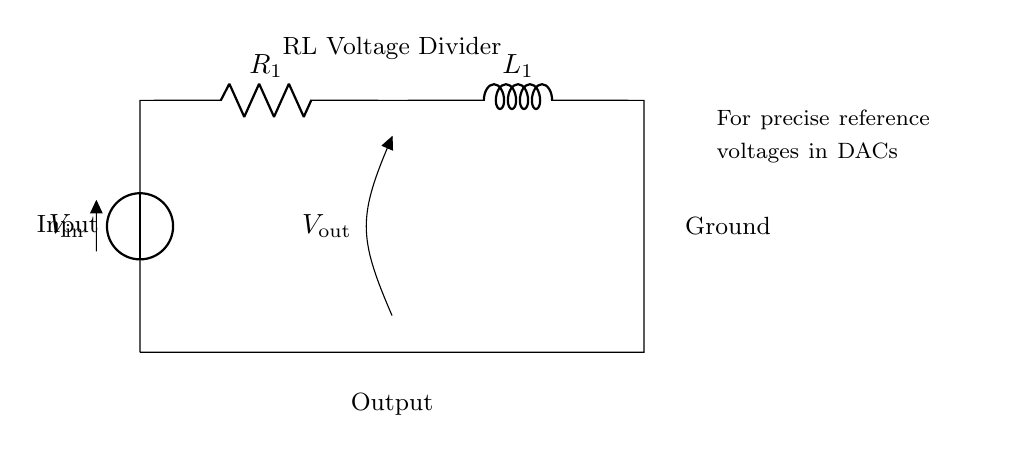What is the input voltage in the circuit? The input voltage is represented as \( V_{\text{in}} \) in the diagram. It is positioned at the top left of the circuit and connected to the voltage source symbol.
Answer: \( V_{\text{in}} \) What is the output voltage noted in the circuit? The output voltage is denoted as \( V_{\text{out}} \) and is shown as an open terminal at the output side, indicating where the reference voltage is taken.
Answer: \( V_{\text{out}} \) How many components are in the circuit? The components in the circuit include one voltage source, one resistor, and one inductor. Counting each symbol gives a total of three distinct components.
Answer: 3 What is the role of the resistor in this circuit? The resistor, labeled \( R_1 \), functions to limit the current flow and create a voltage drop across it, which is crucial in a voltage divider setup.
Answer: Limit current What type of circuit is represented? This circuit is an RL voltage divider using a resistor and an inductor, which is specifically tailored to produce precise reference voltages, especially useful in DACs.
Answer: RL voltage divider What happens to the output voltage when the resistance increases? Increasing the resistance \( R_1 \) will increase the voltage drop across it, and thus, the output voltage \( V_{\text{out}} \) will increase, resulting in a lower voltage across the inductor, owing to the voltage division principle.
Answer: Increases \( V_{\text{out}} \) Why is this circuit configuration suitable for DACs? This circuit configuration provides a stable reference voltage, which is critical for digital-to-analog converters as they rely on precise voltage levels for accurate analog signal output.
Answer: Stable reference voltage 